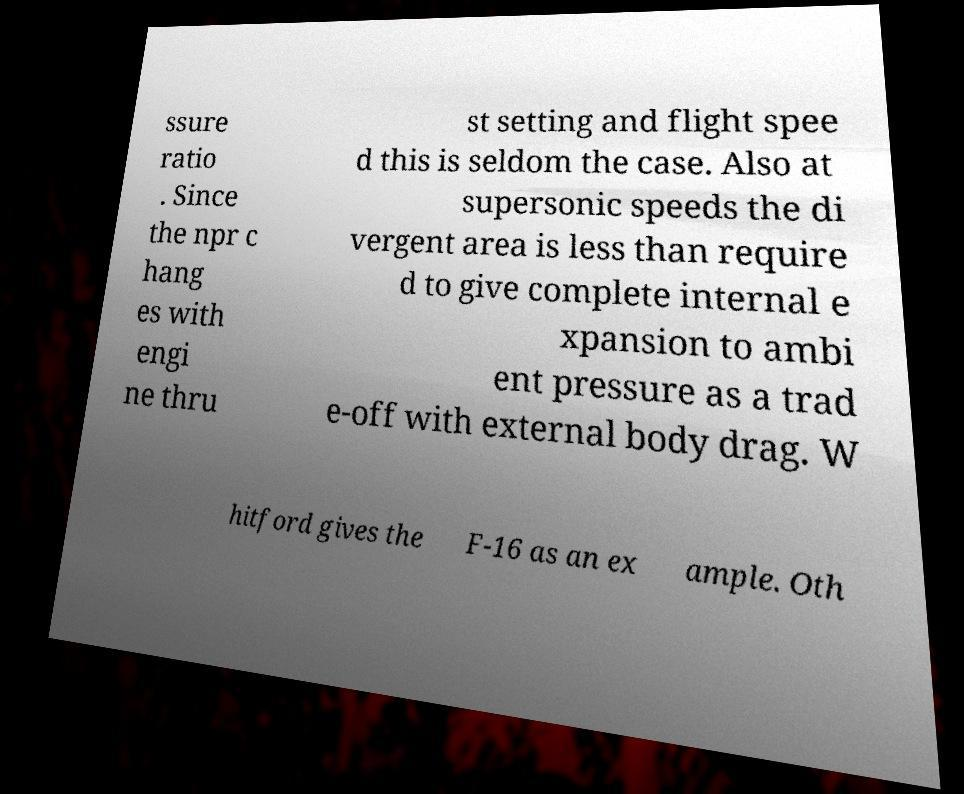Please identify and transcribe the text found in this image. ssure ratio . Since the npr c hang es with engi ne thru st setting and flight spee d this is seldom the case. Also at supersonic speeds the di vergent area is less than require d to give complete internal e xpansion to ambi ent pressure as a trad e-off with external body drag. W hitford gives the F-16 as an ex ample. Oth 